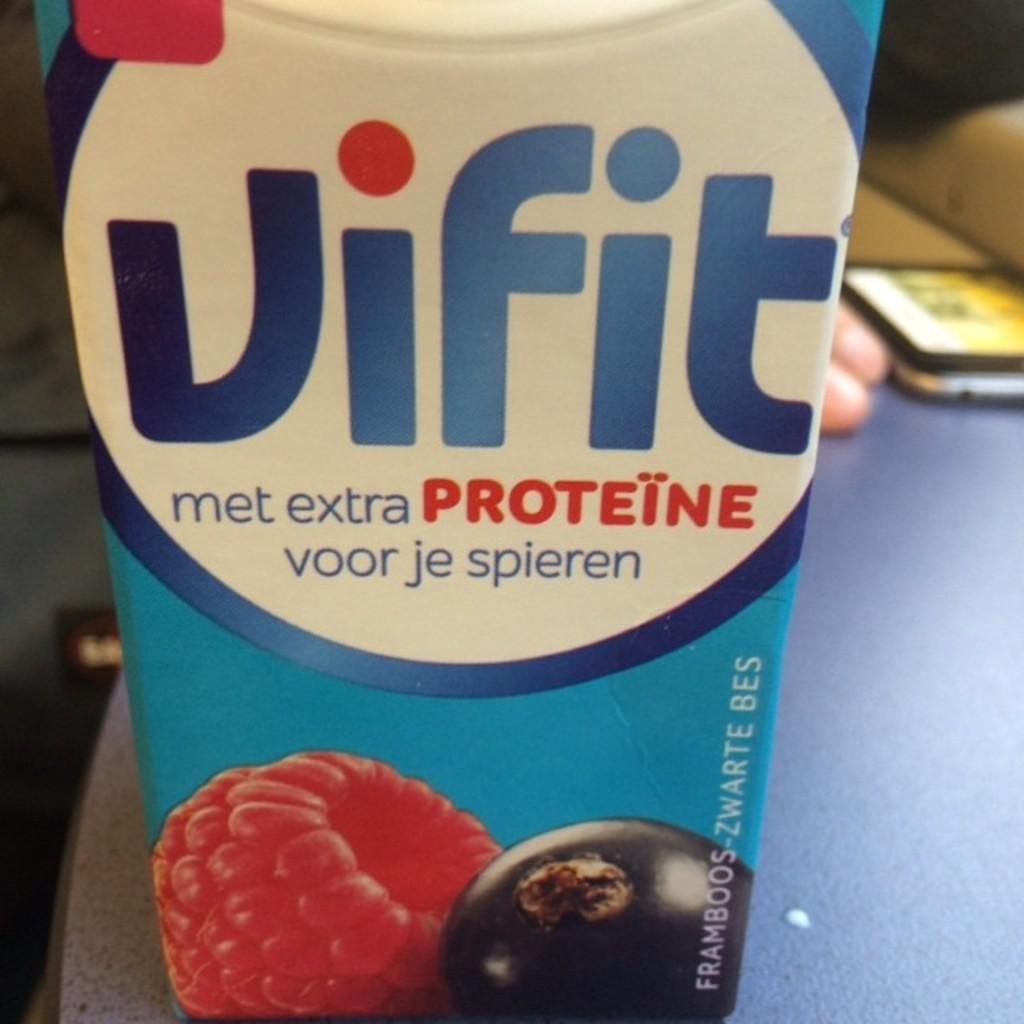In one or two sentences, can you explain what this image depicts? In the image there is a tetra pack fruit juice on a table and behind it seems to be a person. 